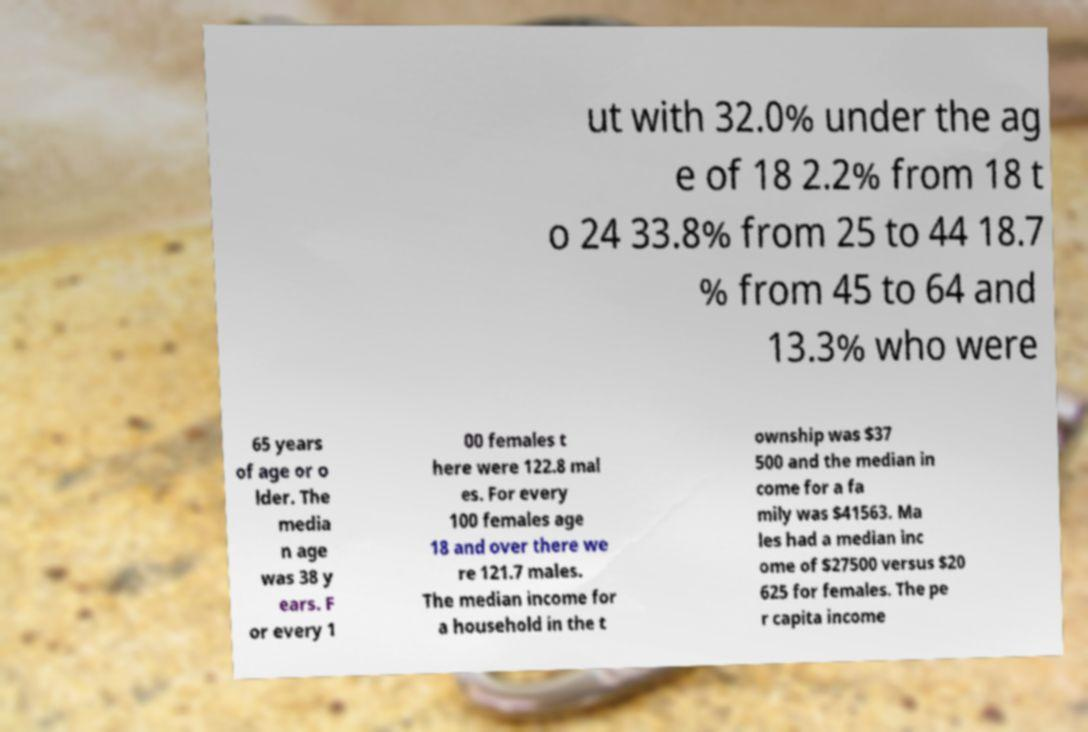I need the written content from this picture converted into text. Can you do that? ut with 32.0% under the ag e of 18 2.2% from 18 t o 24 33.8% from 25 to 44 18.7 % from 45 to 64 and 13.3% who were 65 years of age or o lder. The media n age was 38 y ears. F or every 1 00 females t here were 122.8 mal es. For every 100 females age 18 and over there we re 121.7 males. The median income for a household in the t ownship was $37 500 and the median in come for a fa mily was $41563. Ma les had a median inc ome of $27500 versus $20 625 for females. The pe r capita income 